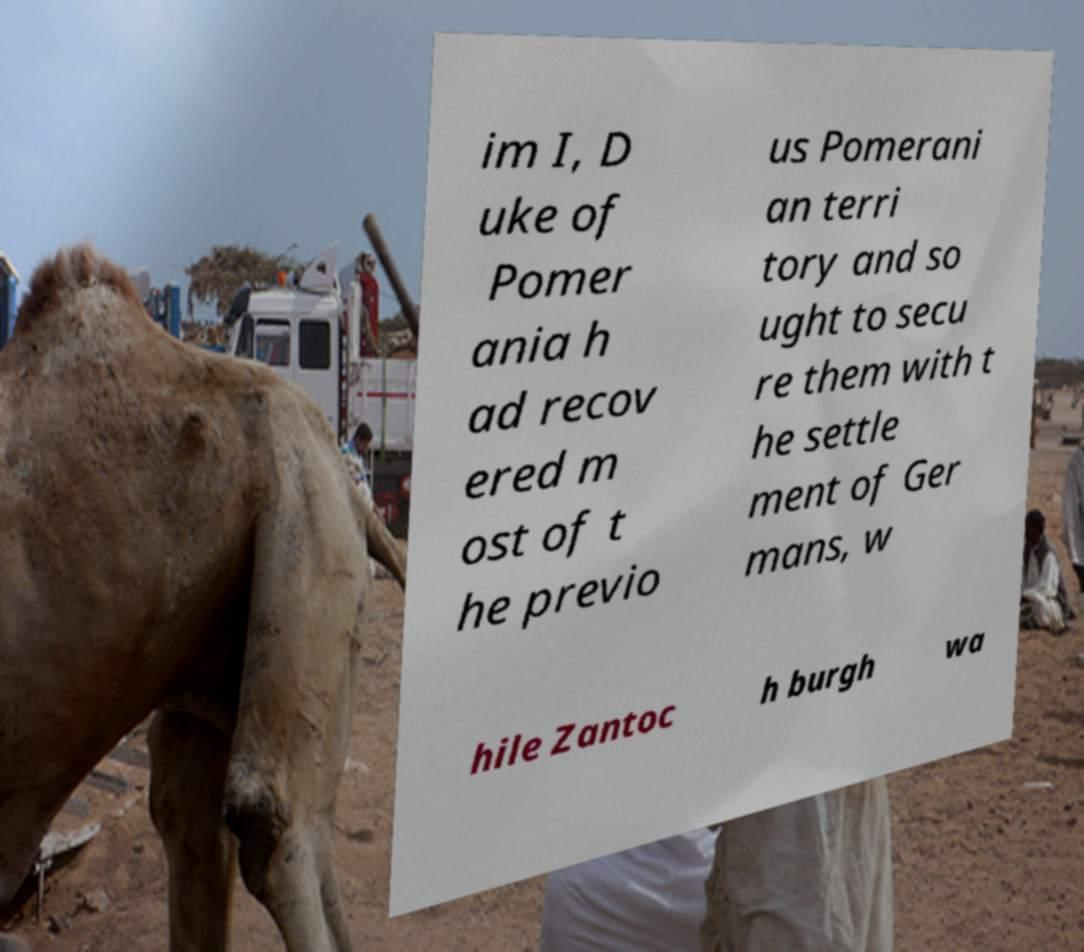Please identify and transcribe the text found in this image. im I, D uke of Pomer ania h ad recov ered m ost of t he previo us Pomerani an terri tory and so ught to secu re them with t he settle ment of Ger mans, w hile Zantoc h burgh wa 